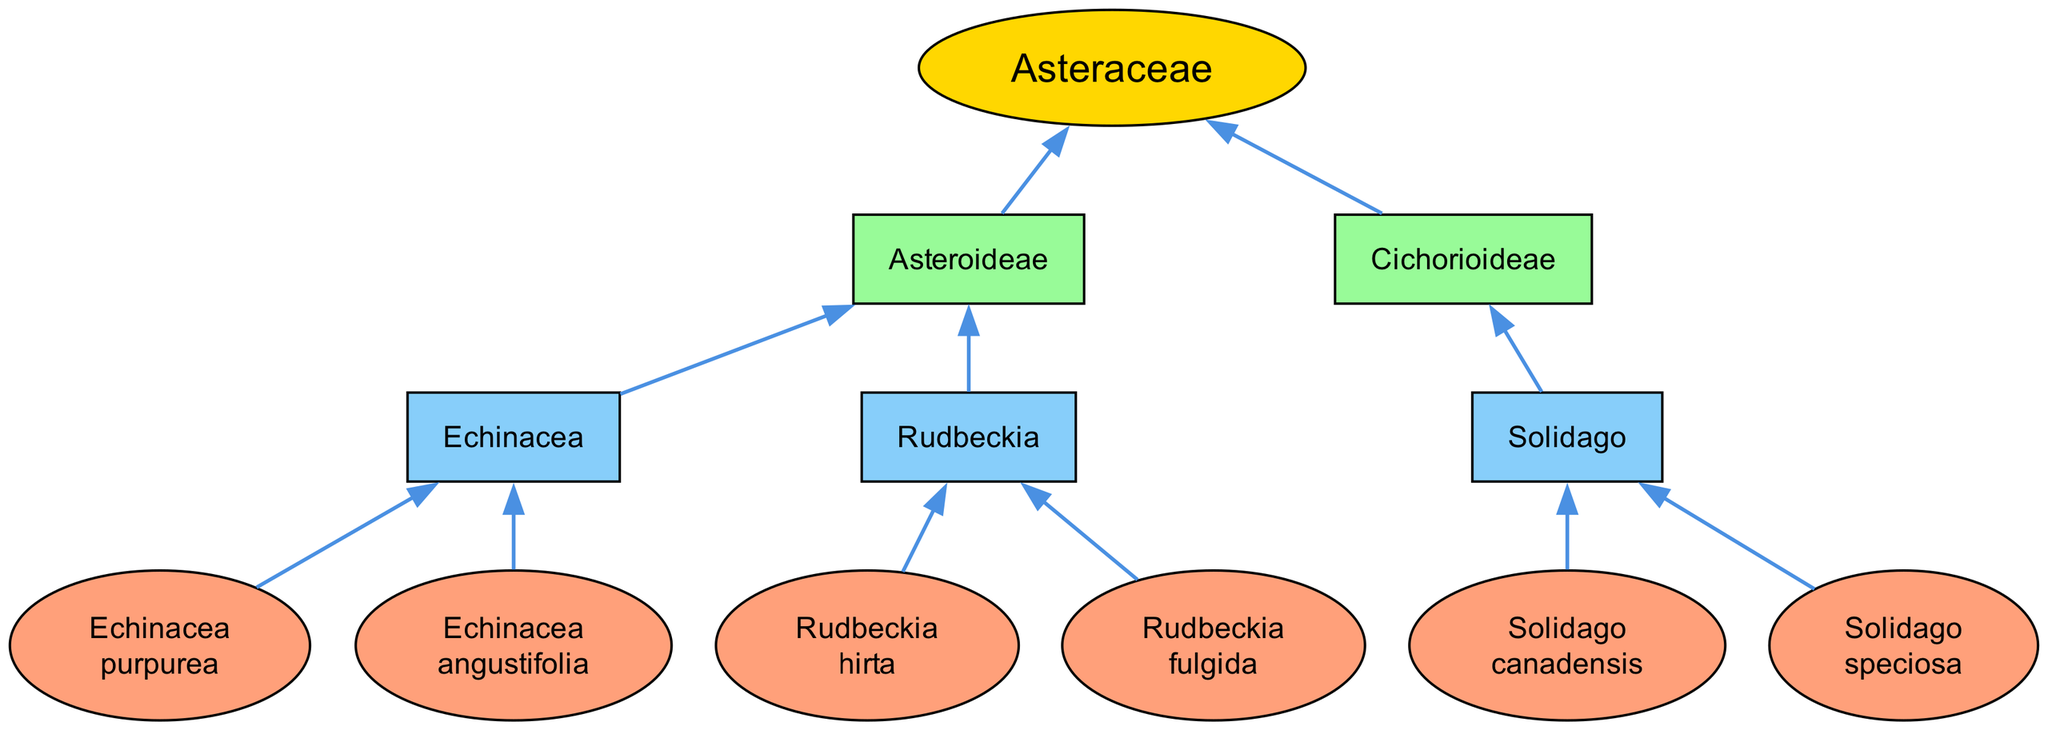What is the family name of the native plant species in the diagram? The top node labeled "Family" represents the classification for the plants shown. It is "Asteraceae."
Answer: Asteraceae How many subfamilies are present in the diagram? The diagram displays two subfamilies stemming from the "Family" node, which are "Asteroideae" and "Cichorioideae."
Answer: 2 Which genus is a part of the "Asteroideae" subfamily? Among the genera listed under the "Asteroideae" subfamily, one is "Echinacea."
Answer: Echinacea How many species are listed under the genus "Rudbeckia"? The genus "Rudbeckia" has two species connected to it in the diagram: "Rudbeckia hirta" and "Rudbeckia fulgida."
Answer: 2 What relationship exists between "Solidago" and "Cichorioideae"? The genus "Solidago" is directly connected to the "Cichorioideae" subfamily, indicating that it belongs to that classification.
Answer: Belongs to Which genus has the species "Echinacea purpurea"? The species "Echinacea purpurea" is categorized under the genus "Echinacea," as depicted in the diagram.
Answer: Echinacea What color represents the genera nodes in the diagram? The genus nodes are filled with a light blue color, which is specified in the attributes of the graph.
Answer: Light blue Which subfamily contains only one genus? The "Cichorioideae" subfamily only includes one genus, which is "Solidago."
Answer: Cichorioideae How many species are associated with the "Echinacea" genus? "Echinacea" has two species listed: "Echinacea purpurea" and "Echinacea angustifolia."
Answer: 2 